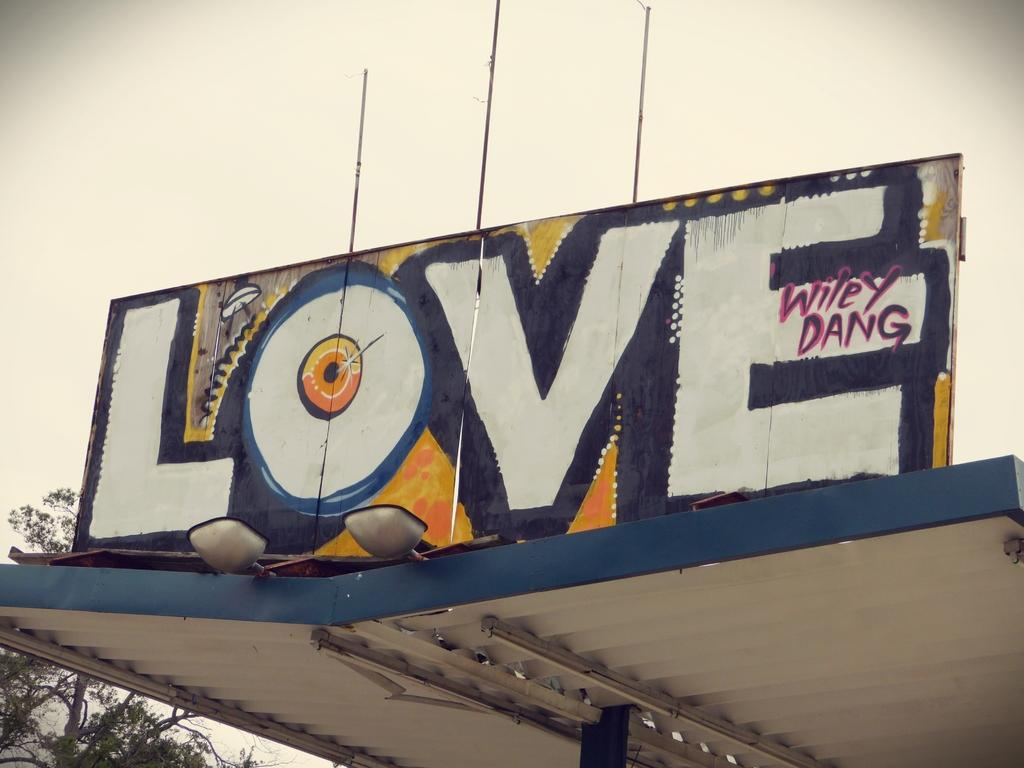Provide a one-sentence caption for the provided image. A graffiti sign has the word LOVE painted on it. 